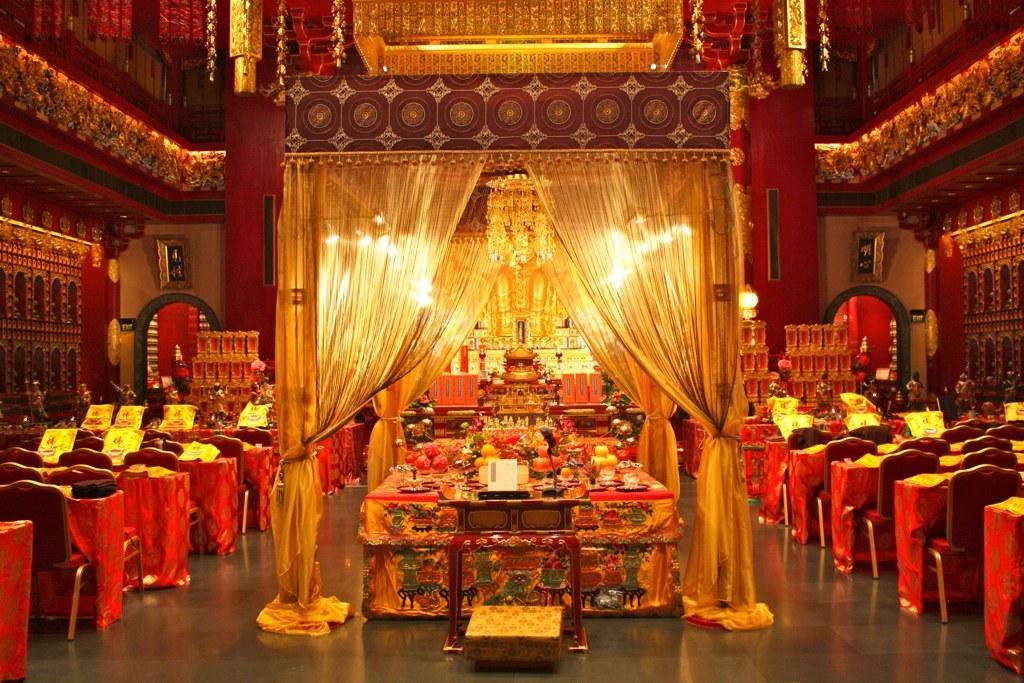How would you summarize this image in a sentence or two? In this image we can see food items on the table. There is a curtain near the table. Beside the table, we can see a group of tables and chairs. On the both sides of the image we can see the walls. In the background, we can see the wall, chandelier and glasses. At the top we can see the lights. 